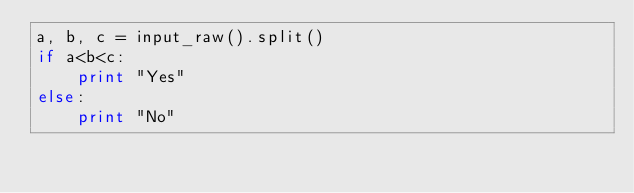Convert code to text. <code><loc_0><loc_0><loc_500><loc_500><_Python_>a, b, c = input_raw().split()
if a<b<c:
    print "Yes"
else:
    print "No"</code> 